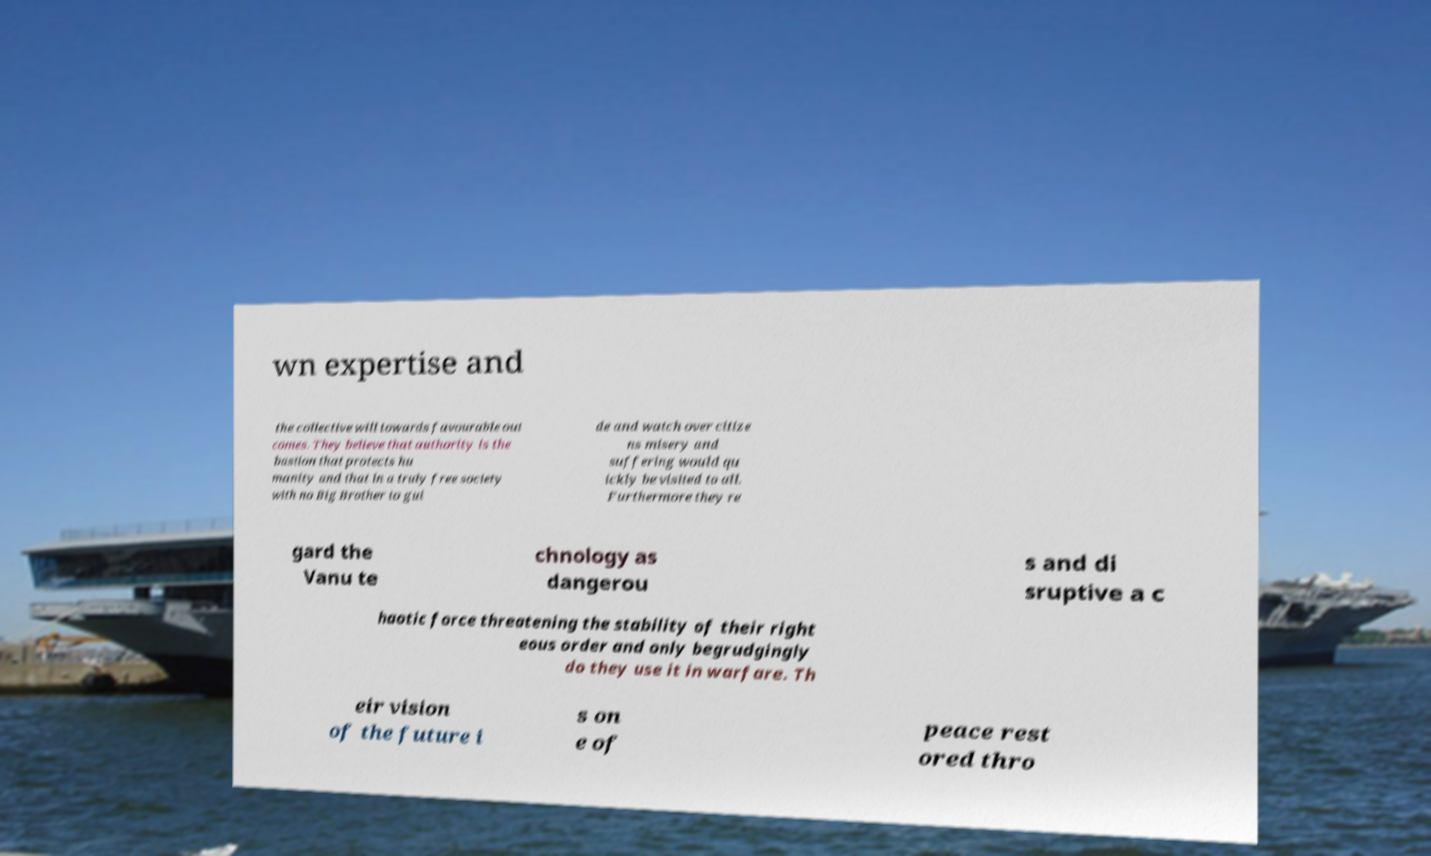For documentation purposes, I need the text within this image transcribed. Could you provide that? wn expertise and the collective will towards favourable out comes. They believe that authority is the bastion that protects hu manity and that in a truly free society with no Big Brother to gui de and watch over citize ns misery and suffering would qu ickly be visited to all. Furthermore they re gard the Vanu te chnology as dangerou s and di sruptive a c haotic force threatening the stability of their right eous order and only begrudgingly do they use it in warfare. Th eir vision of the future i s on e of peace rest ored thro 